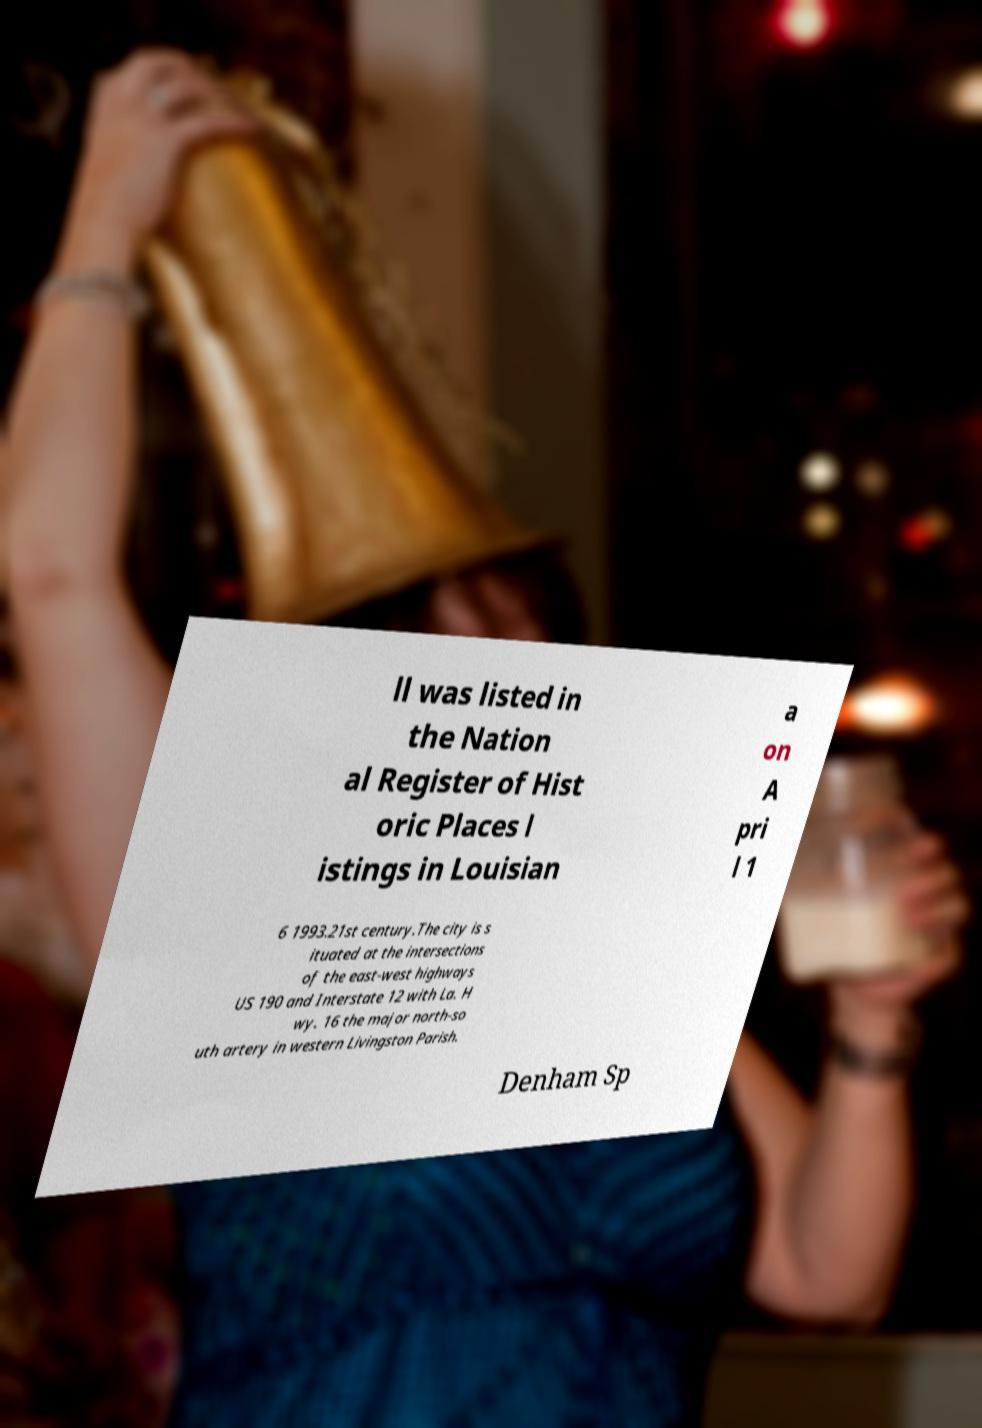Can you read and provide the text displayed in the image?This photo seems to have some interesting text. Can you extract and type it out for me? ll was listed in the Nation al Register of Hist oric Places l istings in Louisian a on A pri l 1 6 1993.21st century.The city is s ituated at the intersections of the east-west highways US 190 and Interstate 12 with La. H wy. 16 the major north-so uth artery in western Livingston Parish. Denham Sp 